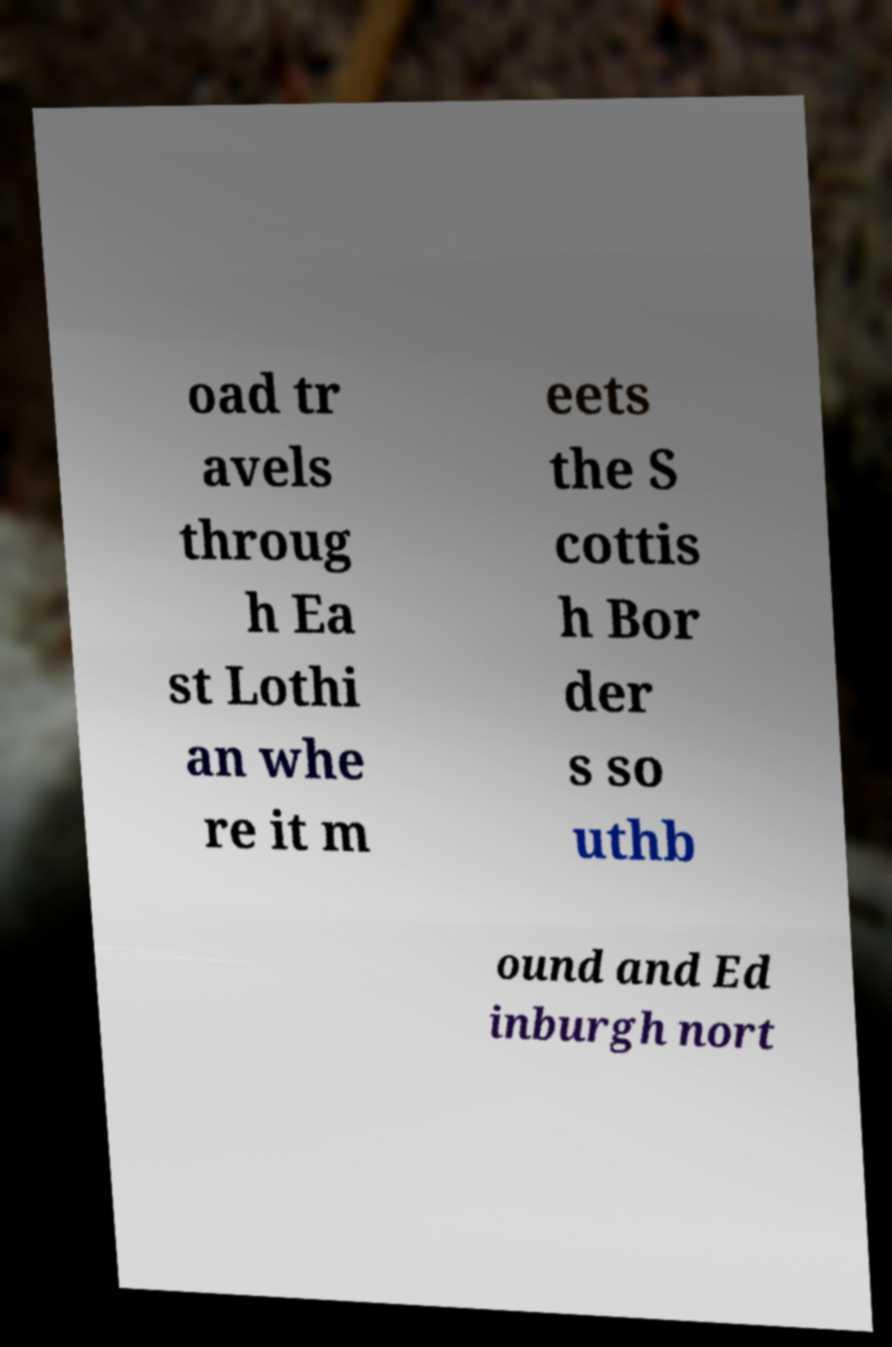Please read and relay the text visible in this image. What does it say? oad tr avels throug h Ea st Lothi an whe re it m eets the S cottis h Bor der s so uthb ound and Ed inburgh nort 